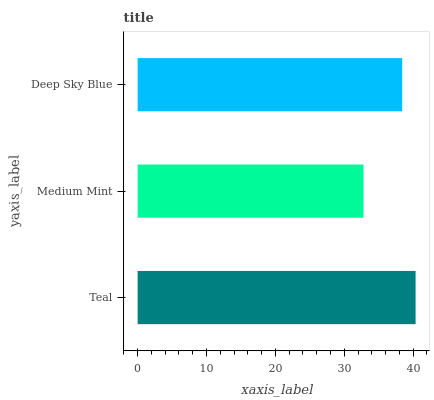Is Medium Mint the minimum?
Answer yes or no. Yes. Is Teal the maximum?
Answer yes or no. Yes. Is Deep Sky Blue the minimum?
Answer yes or no. No. Is Deep Sky Blue the maximum?
Answer yes or no. No. Is Deep Sky Blue greater than Medium Mint?
Answer yes or no. Yes. Is Medium Mint less than Deep Sky Blue?
Answer yes or no. Yes. Is Medium Mint greater than Deep Sky Blue?
Answer yes or no. No. Is Deep Sky Blue less than Medium Mint?
Answer yes or no. No. Is Deep Sky Blue the high median?
Answer yes or no. Yes. Is Deep Sky Blue the low median?
Answer yes or no. Yes. Is Medium Mint the high median?
Answer yes or no. No. Is Teal the low median?
Answer yes or no. No. 